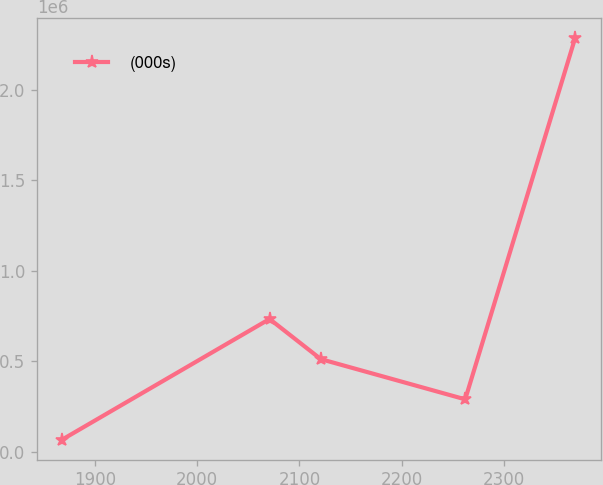Convert chart to OTSL. <chart><loc_0><loc_0><loc_500><loc_500><line_chart><ecel><fcel>(000s)<nl><fcel>1868.14<fcel>67424.2<nl><fcel>2070.86<fcel>733544<nl><fcel>2121.02<fcel>511504<nl><fcel>2262.18<fcel>289464<nl><fcel>2369.77<fcel>2.28782e+06<nl></chart> 